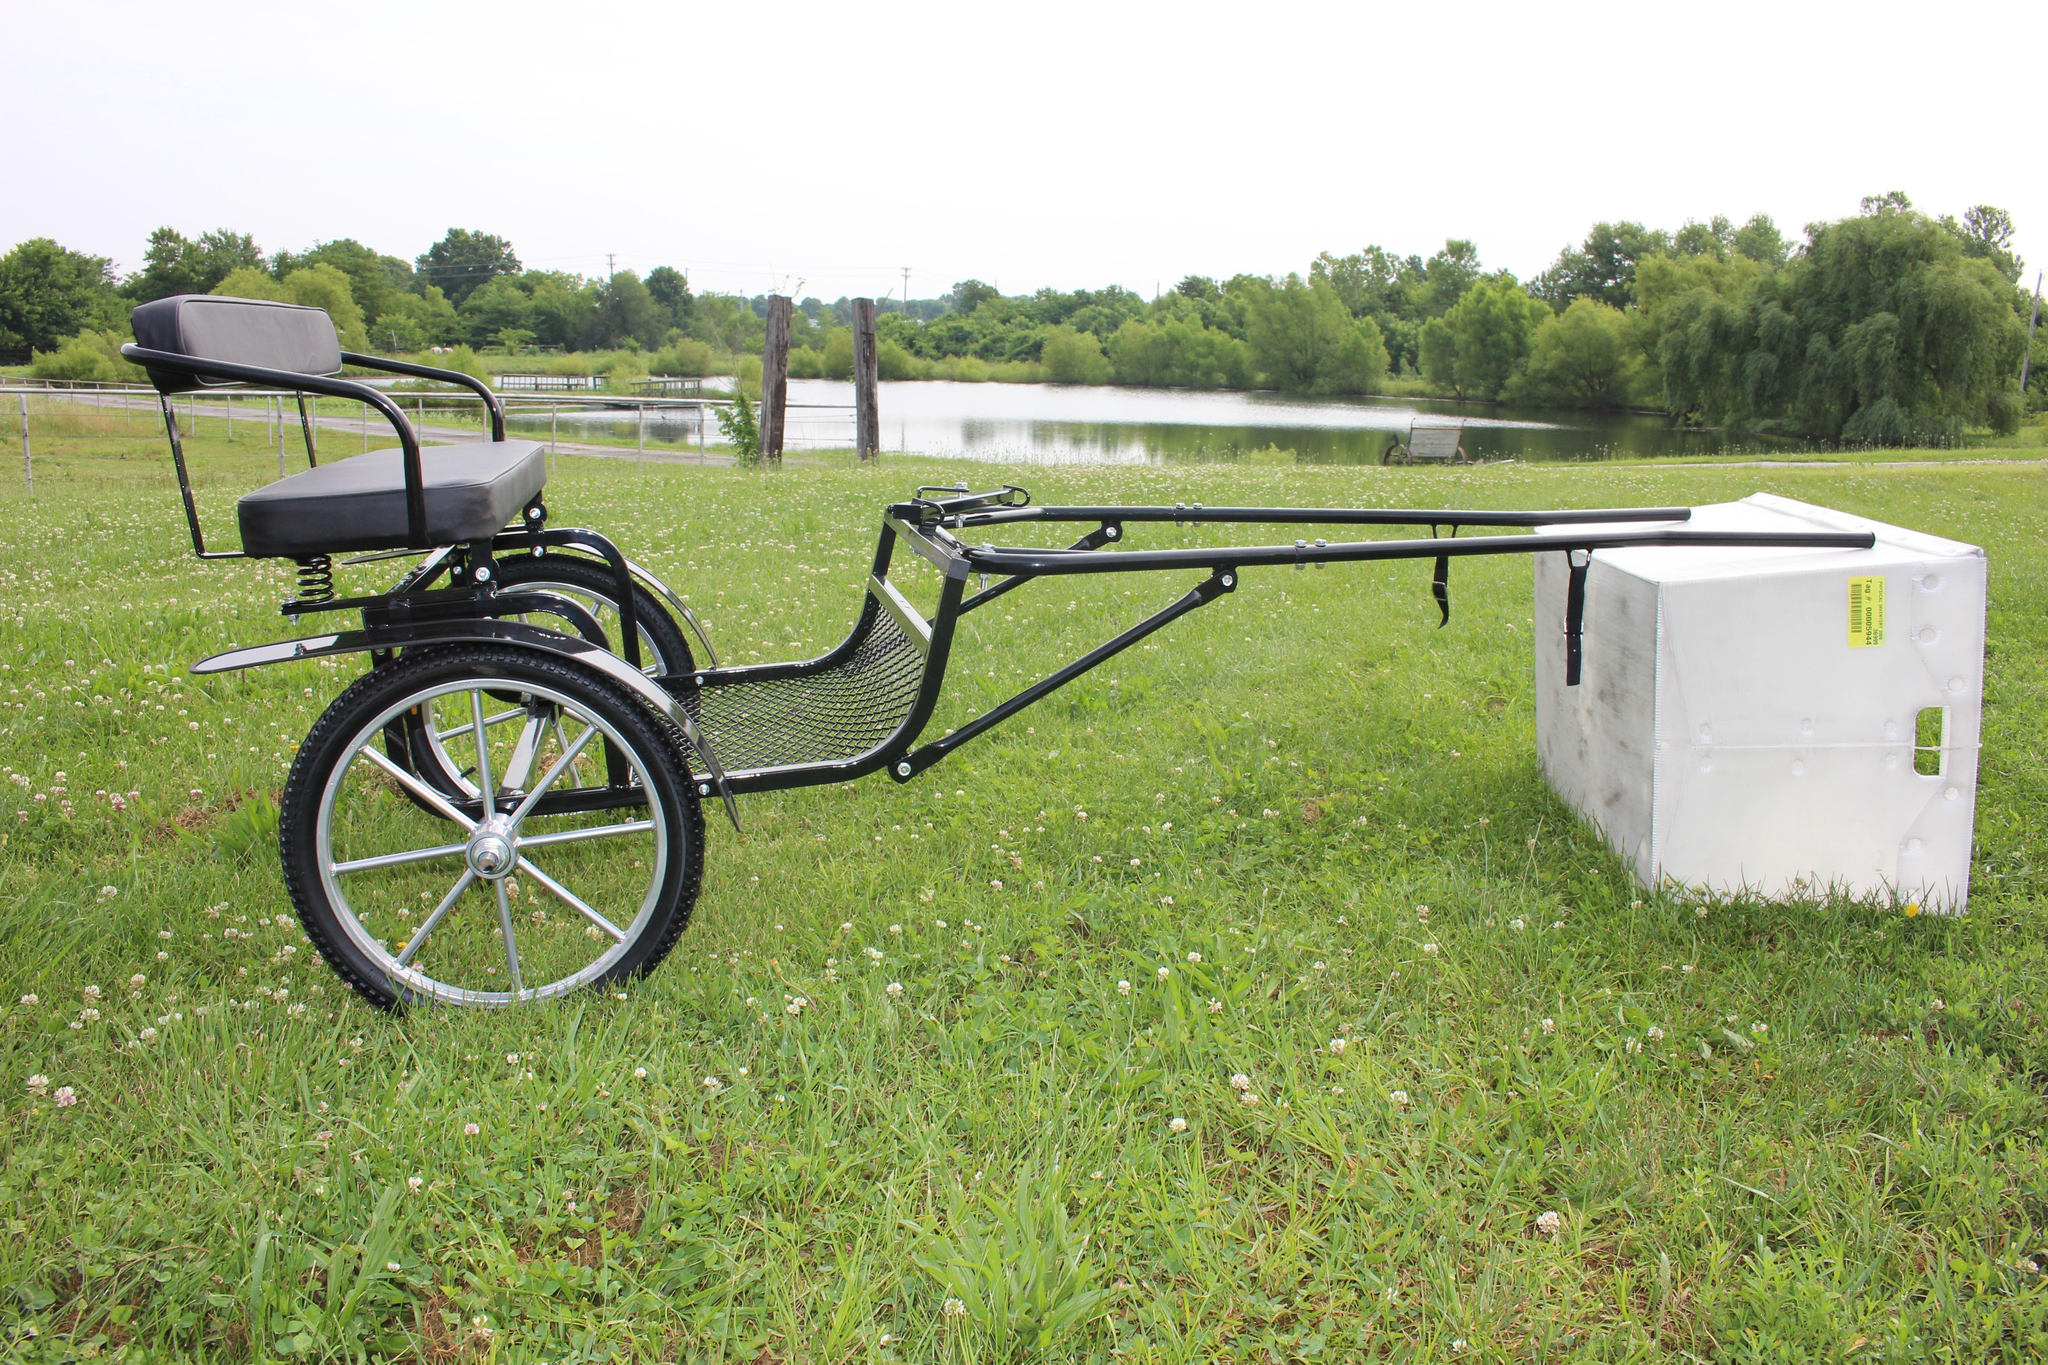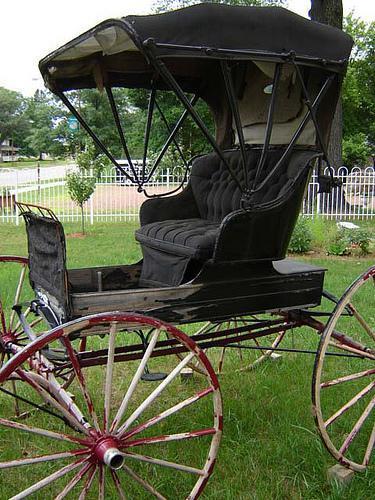The first image is the image on the left, the second image is the image on the right. For the images shown, is this caption "An image shows a four-wheeled buggy with a canopy over an upholstered seat." true? Answer yes or no. Yes. 